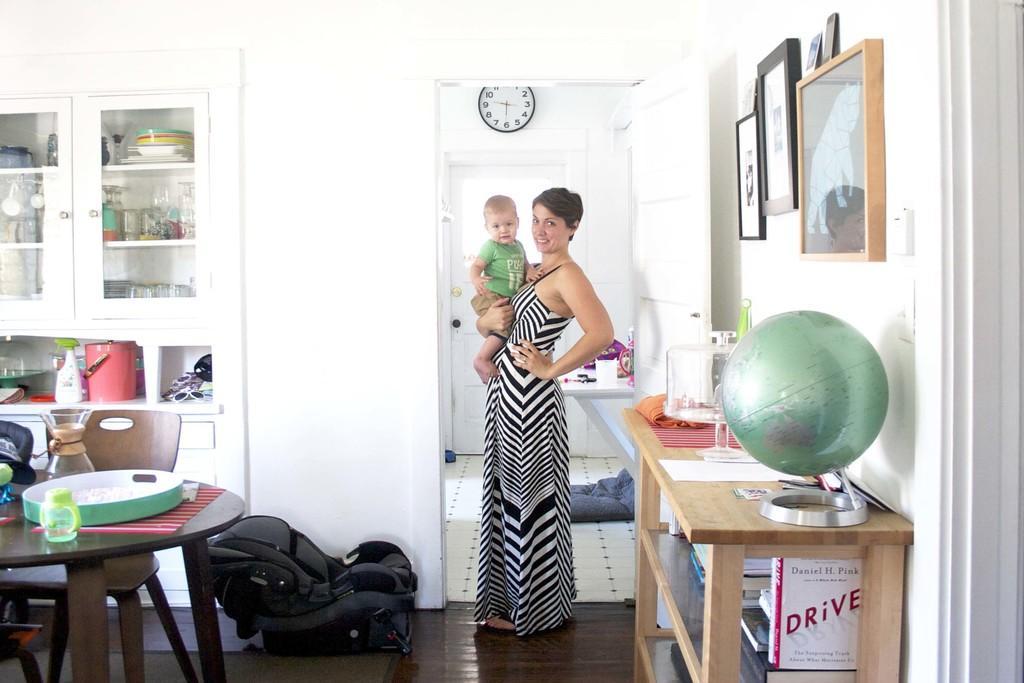Could you give a brief overview of what you see in this image? In this image I can see a woman carrying a baby in her hands. This is an image clicked inside the room. In front of the woman there is a bag. On the left side of the image there is a table and chairs are arranged around this table. Behind the table there is a cupboard. Few bowls, bottles, cups are arranged in it. To the right side wall three frames are attached. Just below this frames there is a table. 